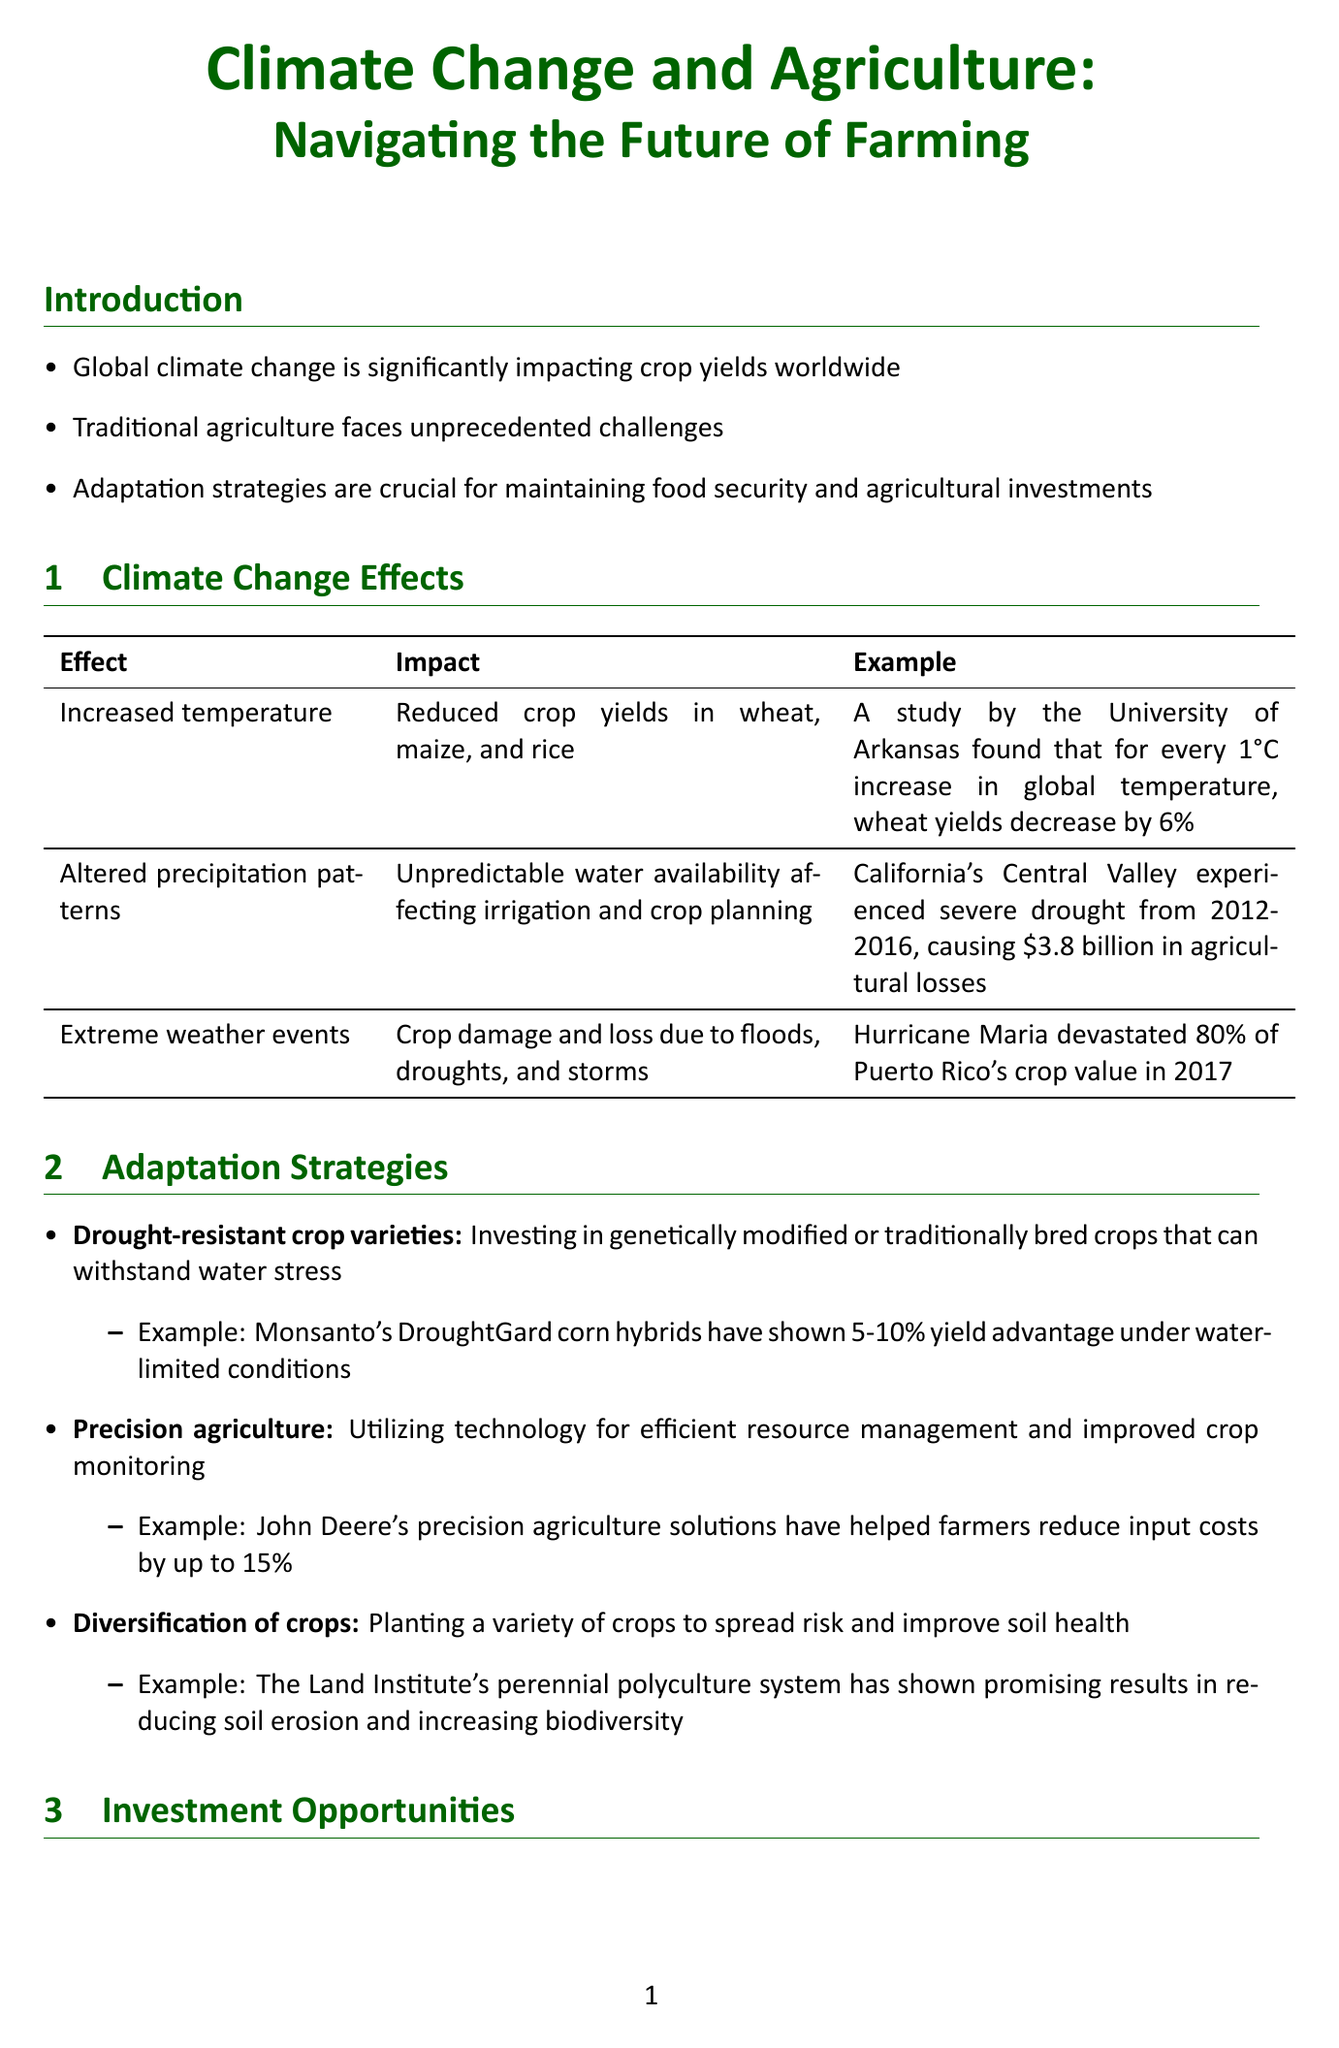what is the newsletter title? The newsletter title is stated at the beginning of the document.
Answer: Climate Change and Agriculture: Navigating the Future of Farming what is the impact of increased temperature on crop yields? The impact of increased temperature is described in the section discussing climate change effects.
Answer: Reduced crop yields in wheat, maize, and rice how much did California's Central Valley lose during the drought from 2012-2016? This information is provided as an example under altered precipitation patterns.
Answer: 3.8 billion what are Monsanto's DroughtGard corn hybrids capable of under water-limited conditions? This information relates to the adaptation strategy of drought-resistant crop varieties.
Answer: 5-10% yield advantage which AgTech startup raised $200 million in 2020? This is mentioned under investment opportunities in the AgTech sector.
Answer: Indigo Agriculture what is one of the adaptation strategies for climate change? The document lists several strategies for adaptation; one can be extracted from the adaptation strategies section.
Answer: Drought-resistant crop varieties what climate change effect caused Hurricane Maria to devastate crop value in 2017? The specific effect is explained in the extreme weather events section.
Answer: Extreme weather events what is the investment opportunity related to water management technologies? This is discussed in the investment opportunities section of the newsletter.
Answer: Efficient irrigation and water conservation in agriculture 